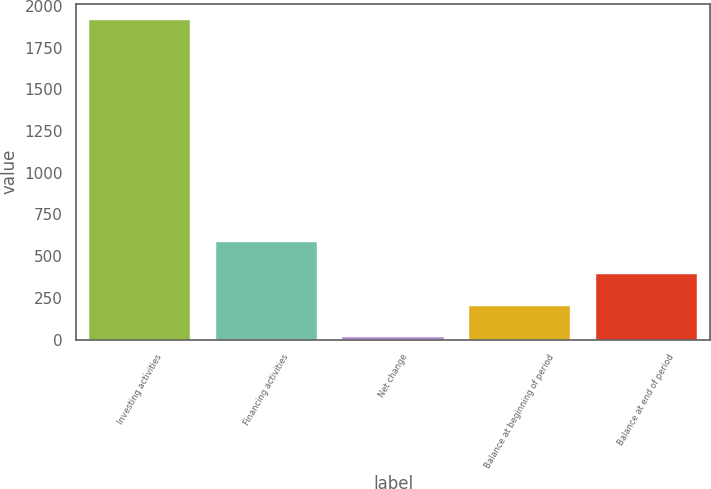Convert chart to OTSL. <chart><loc_0><loc_0><loc_500><loc_500><bar_chart><fcel>Investing activities<fcel>Financing activities<fcel>Net change<fcel>Balance at beginning of period<fcel>Balance at end of period<nl><fcel>1918<fcel>584.5<fcel>13<fcel>203.5<fcel>394<nl></chart> 